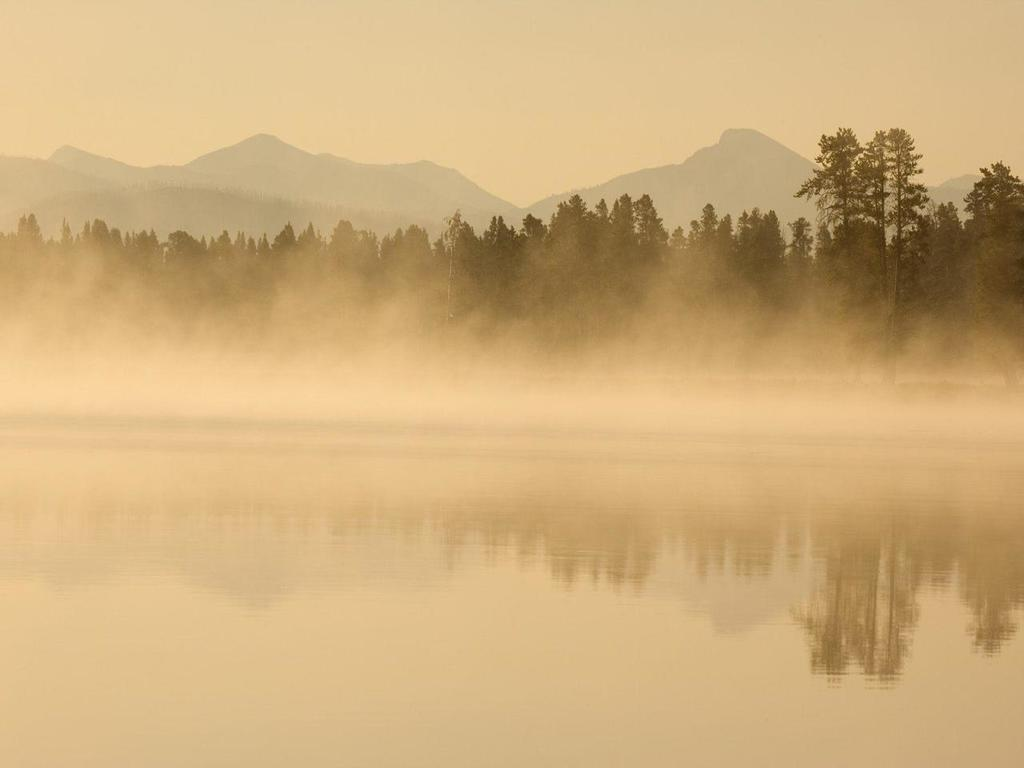What is the primary element visible in the image? There is water in the image. What is the atmospheric condition in the image? There is fog in the air. What type of vegetation can be seen in the image? There are trees visible in the image. What geographical feature is present in the image? There are mountains in the image. How would you describe the sky in the image? The sky is clear in the image. What topic is being discussed in the image? There is no discussion taking place in the image; it is a visual representation of a landscape with water, fog, trees, mountains, and a clear sky. 